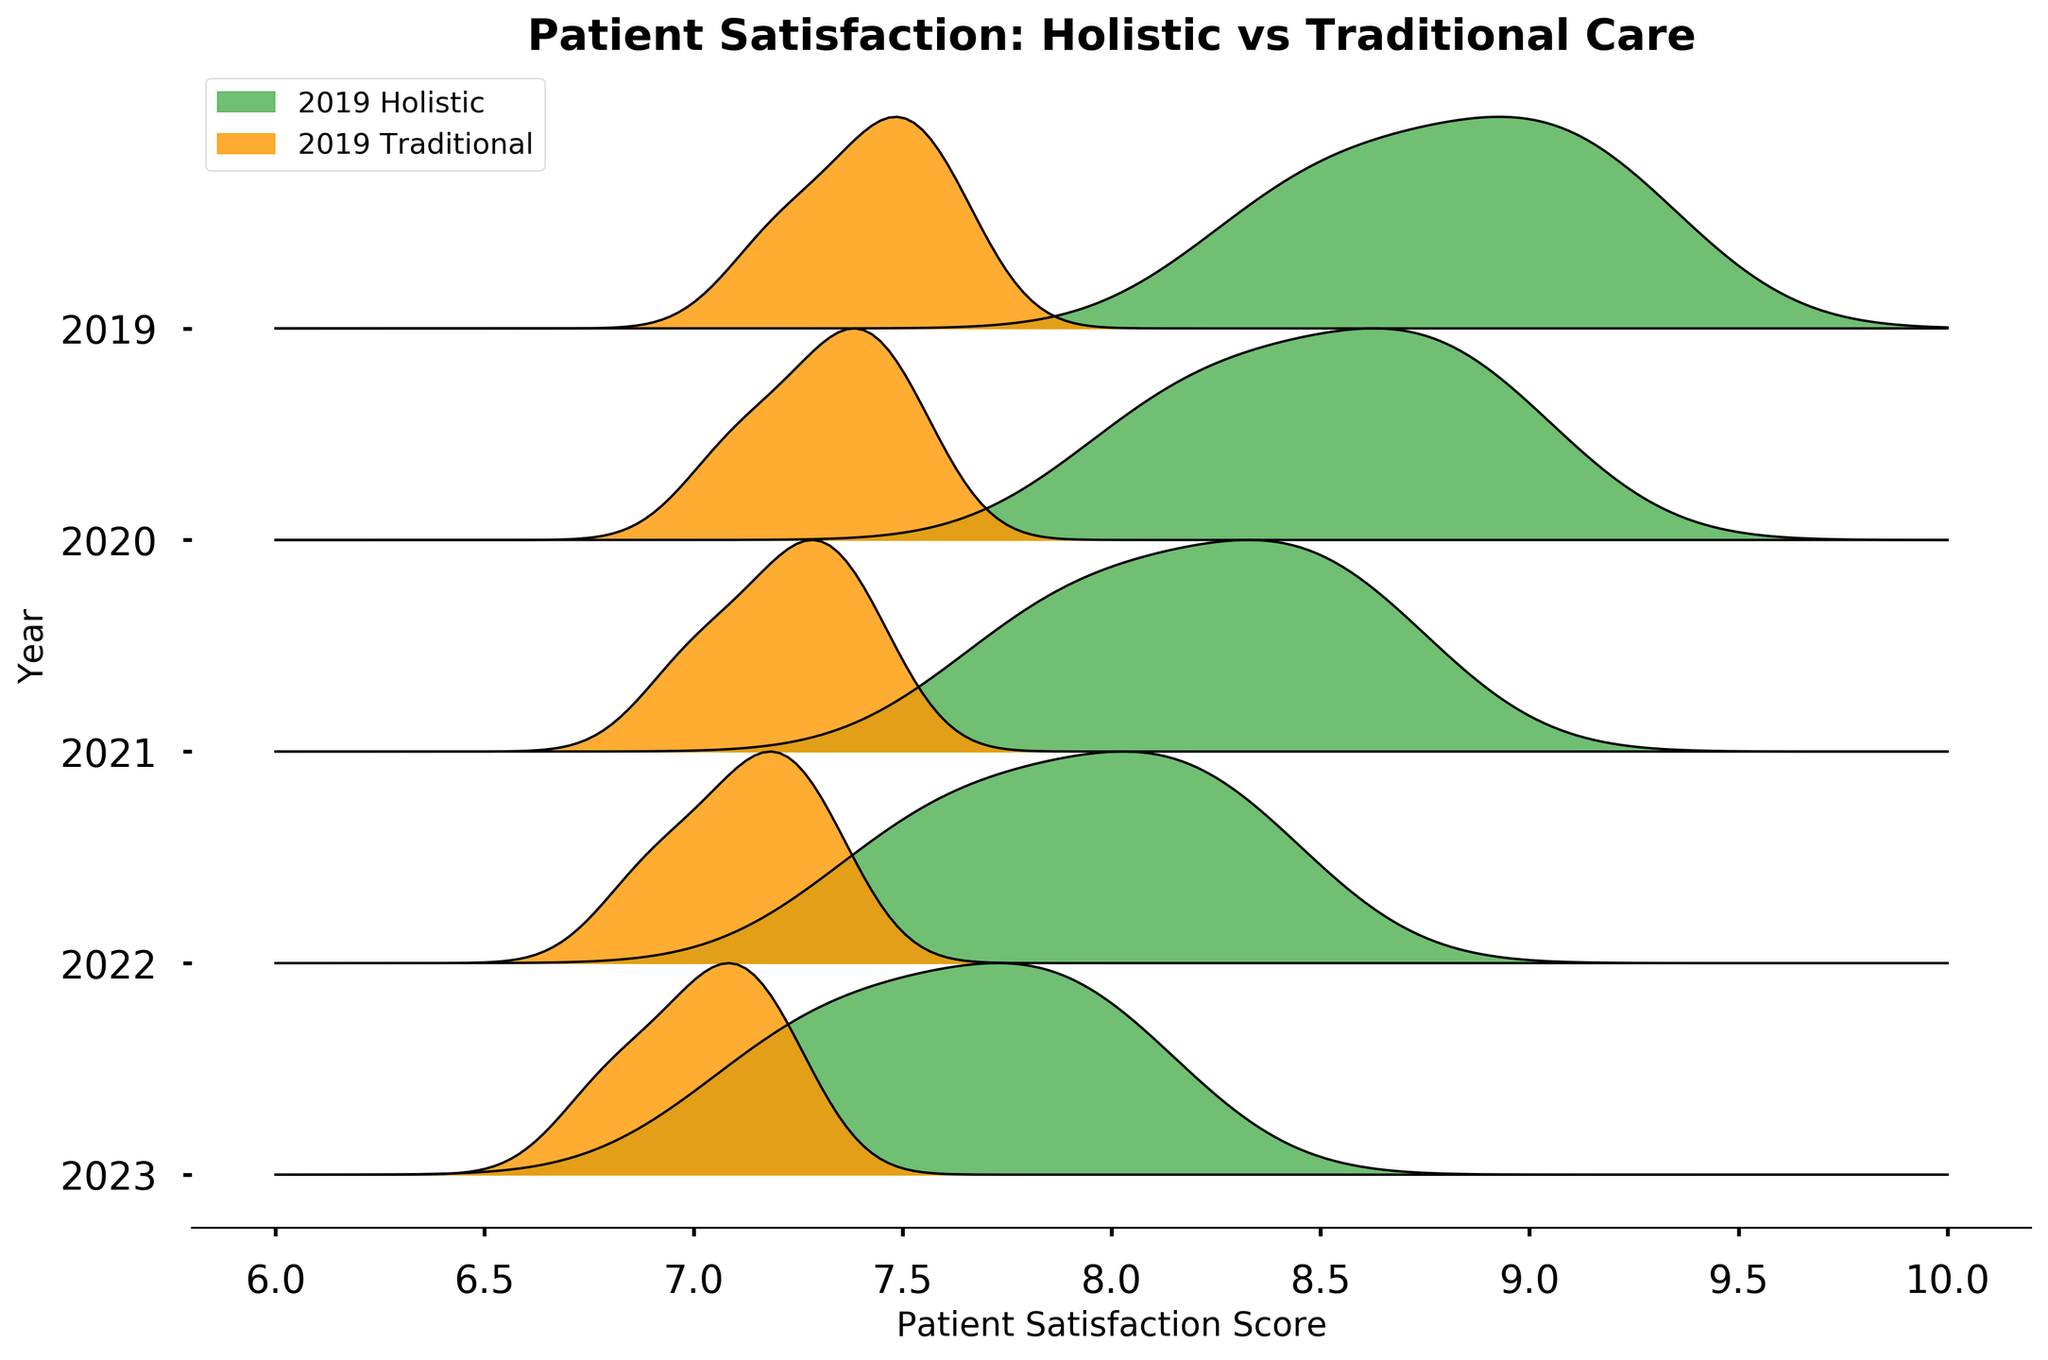How many years of data are shown in the figure? The figure has ridgelines labeled for each year, indicating the range of data covered. Each ridgeline represents data for one year. Counting these labels will give the number of years presented.
Answer: 5 What is the title of the figure? The title is usually placed at the top of the figure, providing a summary of what the figure represents. It helps in quickly understanding the main focus of the plot.
Answer: Patient Satisfaction: Holistic vs Traditional Care In 2021, which approach had the higher patient satisfaction scores? By looking at the ridgelines labeled 2021, we compare the Holistic and Traditional lines. The ridgeline for Holistic care is higher than that of Traditional care in 2021.
Answer: Holistic Over the years, did the patient satisfaction scores for Holistic care improve, decline, or stay the same? To determine the trend, observe the positions of the ridgelines for Holistic care across the years from 2019 to 2023. They show an upward shift in scores.
Answer: Improve In which year did Traditional care have the smallest difference in satisfaction scores compared to Holistic care? To find this, compare the vertical distances between paired ridgelines (Holistic and Traditional) for each year. The smallest gap between their peaks indicates the year with the least difference.
Answer: 2023 Which year shows the most prominent difference between Holistic and Traditional patient satisfaction scores? Examine the vertical distance between the ridgelines for Holistic and Traditional care. The year where this distance is greatest indicates the most prominent difference.
Answer: 2022 How does the peak of the ridgeline for Holistic care in 2019 compare to the peak for Traditional care in 2023? By comparing the vertical positions of the peaks in the respective years, one can determine which is higher or if they are similar. The peak for Holistic in 2019 is still higher than for Traditional in 2023.
Answer: Holistic in 2019 is higher What is the pattern of patient satisfaction scores for Traditional care over the years? Observing the ridgelines for Traditional care from 2019 to 2023, track the trend whether it goes up, down, or stays consistent. The ridgeline shows a slight increasing trend over the years.
Answer: Slightly increasing In which year did Holistic care achieve its highest patient satisfaction scores? By looking at the highest position of the ridgelines for Holistic care, one can identify the year with the highest scores.
Answer: 2023 